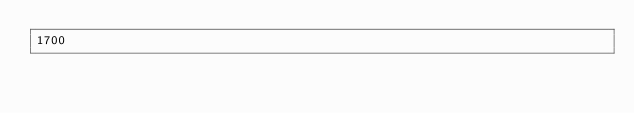Convert code to text. <code><loc_0><loc_0><loc_500><loc_500><_Rust_>1700</code> 